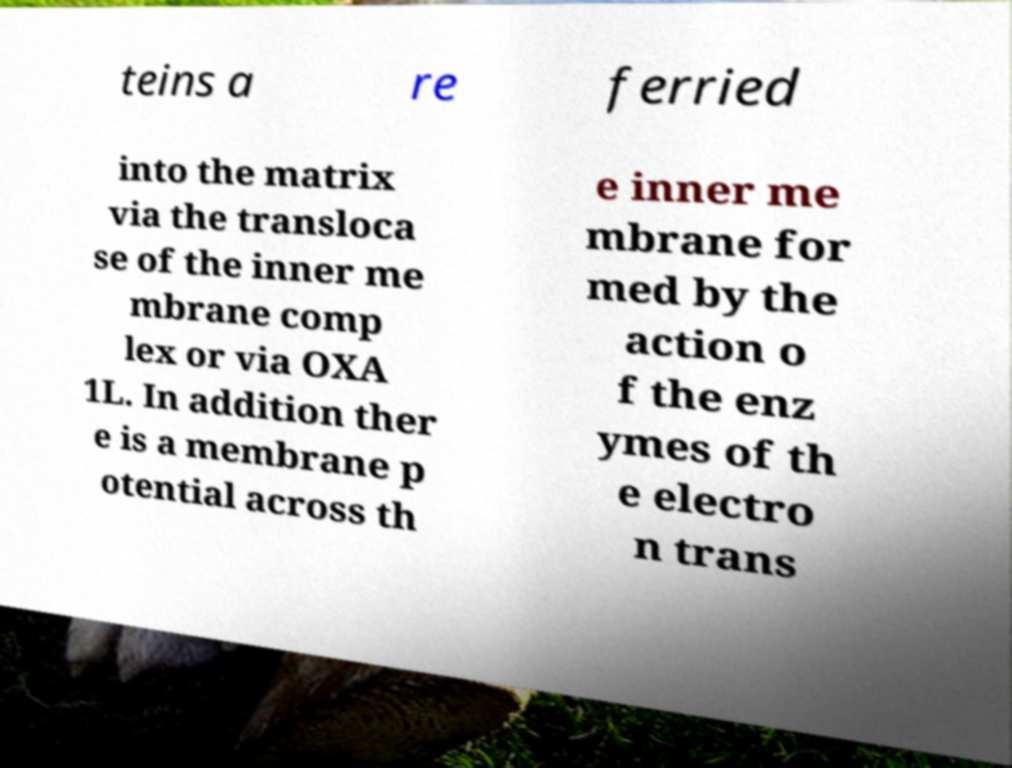Please read and relay the text visible in this image. What does it say? teins a re ferried into the matrix via the transloca se of the inner me mbrane comp lex or via OXA 1L. In addition ther e is a membrane p otential across th e inner me mbrane for med by the action o f the enz ymes of th e electro n trans 